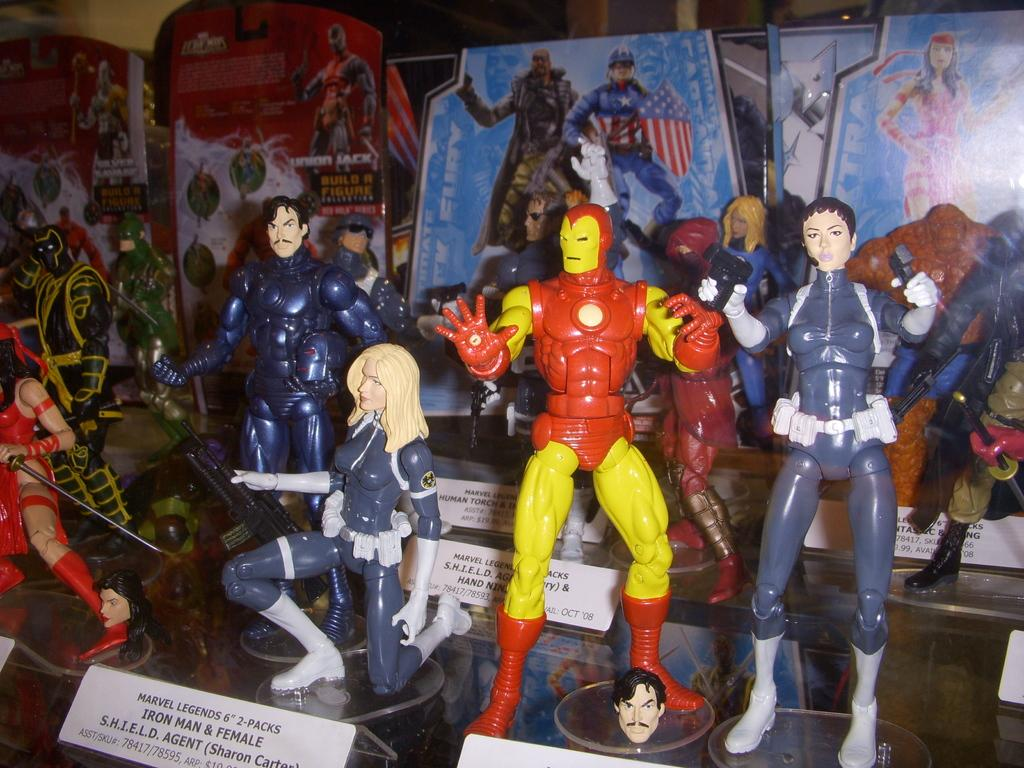What is placed on the glass in the image? There are toys on the glass in the image. What can be seen behind the toys? There are banners with text and images at the back of the toys. What is in front of the toys? There are boards with text and numbers in front of the toys. How many trucks are visible in the image? There are no trucks present in the image. Are there any trains visible in the image? There are no trains present in the image. 